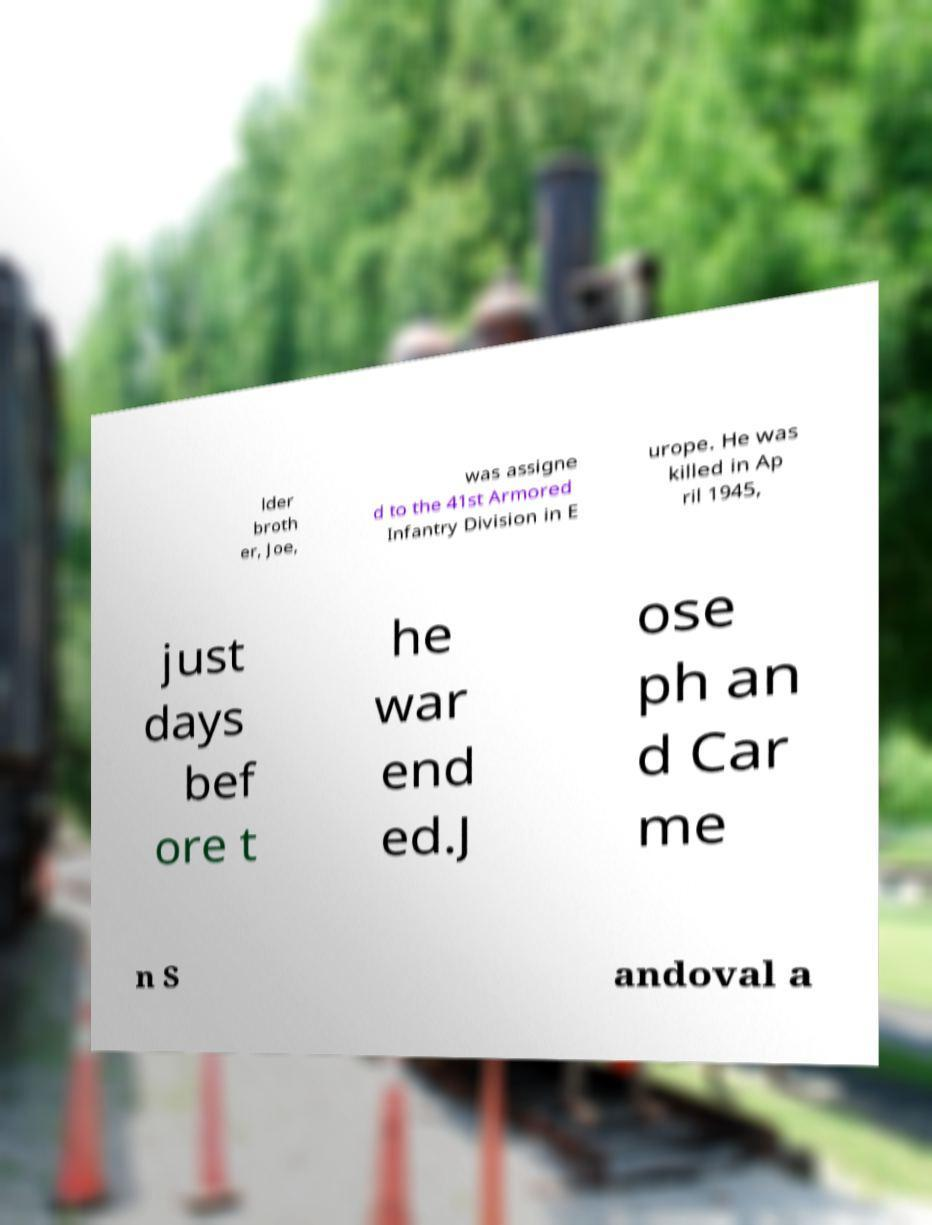Please read and relay the text visible in this image. What does it say? lder broth er, Joe, was assigne d to the 41st Armored Infantry Division in E urope. He was killed in Ap ril 1945, just days bef ore t he war end ed.J ose ph an d Car me n S andoval a 